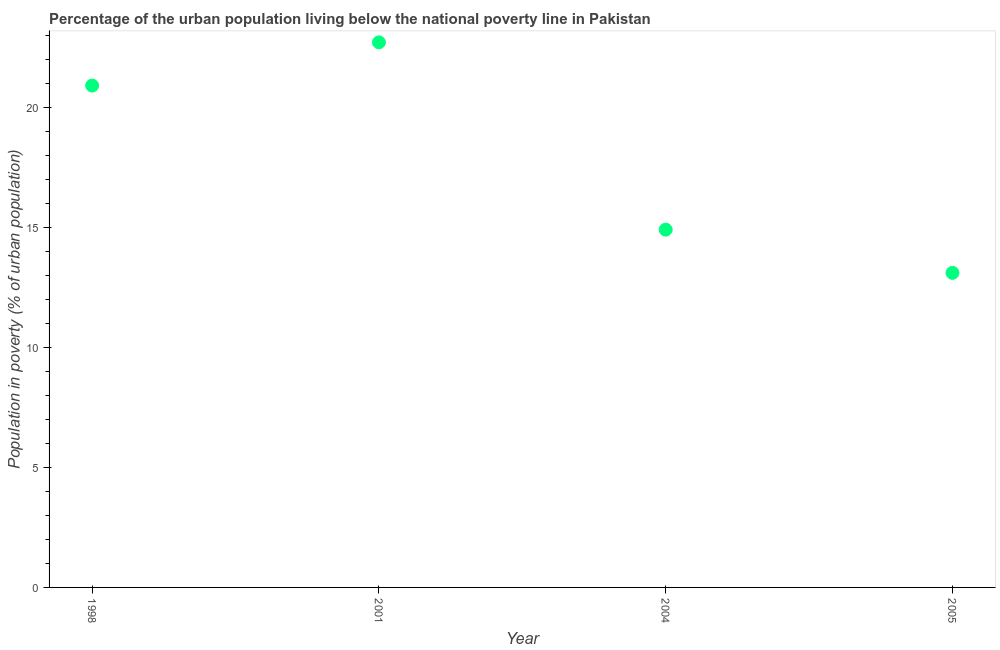What is the percentage of urban population living below poverty line in 2004?
Keep it short and to the point. 14.9. Across all years, what is the maximum percentage of urban population living below poverty line?
Provide a short and direct response. 22.7. Across all years, what is the minimum percentage of urban population living below poverty line?
Offer a terse response. 13.1. In which year was the percentage of urban population living below poverty line maximum?
Your response must be concise. 2001. What is the sum of the percentage of urban population living below poverty line?
Your answer should be very brief. 71.6. What is the difference between the percentage of urban population living below poverty line in 2004 and 2005?
Your answer should be very brief. 1.8. What is the average percentage of urban population living below poverty line per year?
Give a very brief answer. 17.9. What is the ratio of the percentage of urban population living below poverty line in 1998 to that in 2001?
Offer a terse response. 0.92. Is the percentage of urban population living below poverty line in 2001 less than that in 2004?
Your response must be concise. No. Is the difference between the percentage of urban population living below poverty line in 2001 and 2005 greater than the difference between any two years?
Make the answer very short. Yes. What is the difference between the highest and the second highest percentage of urban population living below poverty line?
Keep it short and to the point. 1.8. In how many years, is the percentage of urban population living below poverty line greater than the average percentage of urban population living below poverty line taken over all years?
Keep it short and to the point. 2. Does the percentage of urban population living below poverty line monotonically increase over the years?
Your answer should be compact. No. How many dotlines are there?
Offer a very short reply. 1. How many years are there in the graph?
Ensure brevity in your answer.  4. What is the difference between two consecutive major ticks on the Y-axis?
Provide a succinct answer. 5. Are the values on the major ticks of Y-axis written in scientific E-notation?
Your response must be concise. No. Does the graph contain any zero values?
Provide a succinct answer. No. What is the title of the graph?
Your answer should be compact. Percentage of the urban population living below the national poverty line in Pakistan. What is the label or title of the X-axis?
Provide a succinct answer. Year. What is the label or title of the Y-axis?
Make the answer very short. Population in poverty (% of urban population). What is the Population in poverty (% of urban population) in 1998?
Make the answer very short. 20.9. What is the Population in poverty (% of urban population) in 2001?
Offer a very short reply. 22.7. What is the Population in poverty (% of urban population) in 2004?
Give a very brief answer. 14.9. What is the Population in poverty (% of urban population) in 2005?
Offer a terse response. 13.1. What is the difference between the Population in poverty (% of urban population) in 2001 and 2004?
Your answer should be very brief. 7.8. What is the ratio of the Population in poverty (% of urban population) in 1998 to that in 2001?
Make the answer very short. 0.92. What is the ratio of the Population in poverty (% of urban population) in 1998 to that in 2004?
Provide a short and direct response. 1.4. What is the ratio of the Population in poverty (% of urban population) in 1998 to that in 2005?
Provide a short and direct response. 1.59. What is the ratio of the Population in poverty (% of urban population) in 2001 to that in 2004?
Ensure brevity in your answer.  1.52. What is the ratio of the Population in poverty (% of urban population) in 2001 to that in 2005?
Provide a short and direct response. 1.73. What is the ratio of the Population in poverty (% of urban population) in 2004 to that in 2005?
Make the answer very short. 1.14. 